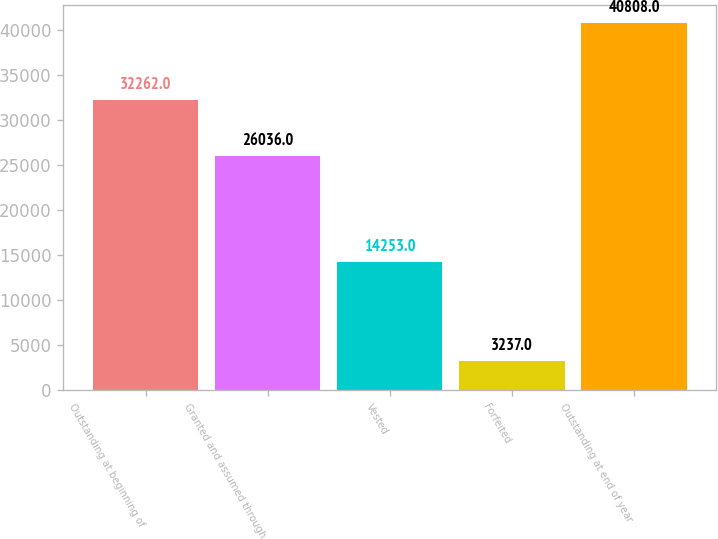Convert chart. <chart><loc_0><loc_0><loc_500><loc_500><bar_chart><fcel>Outstanding at beginning of<fcel>Granted and assumed through<fcel>Vested<fcel>Forfeited<fcel>Outstanding at end of year<nl><fcel>32262<fcel>26036<fcel>14253<fcel>3237<fcel>40808<nl></chart> 